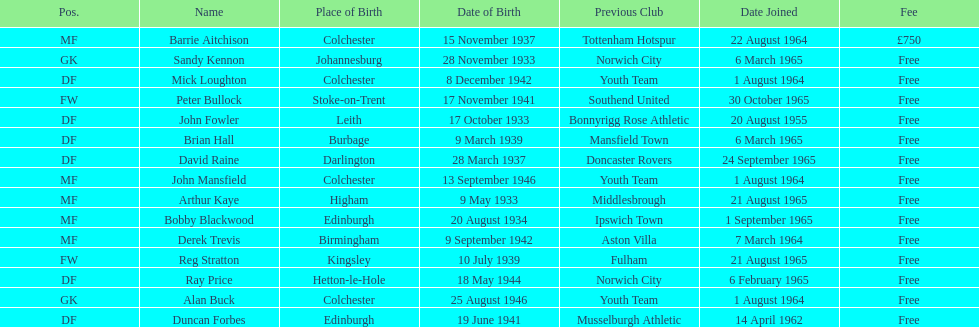What is the date of the lst player that joined? 20 August 1955. 